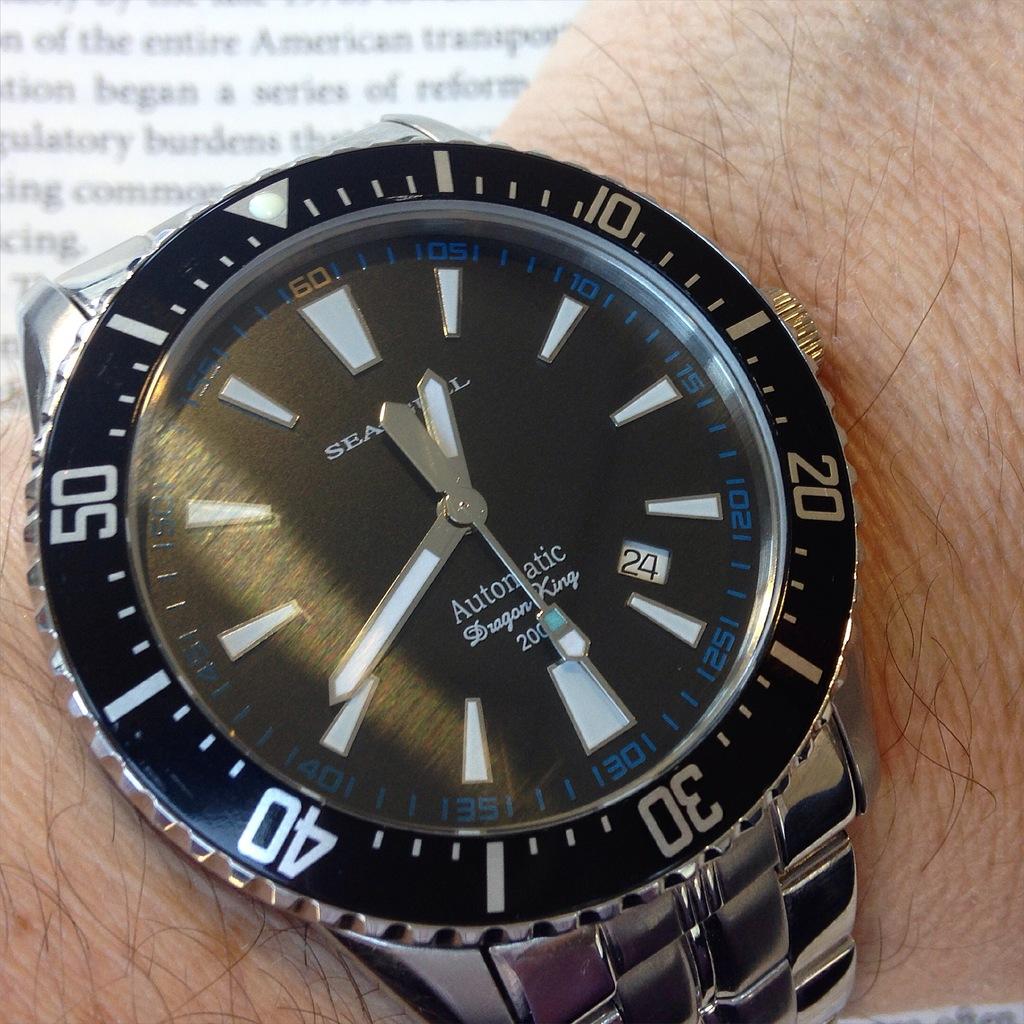Is this an automatic watch?
Make the answer very short. Yes. 